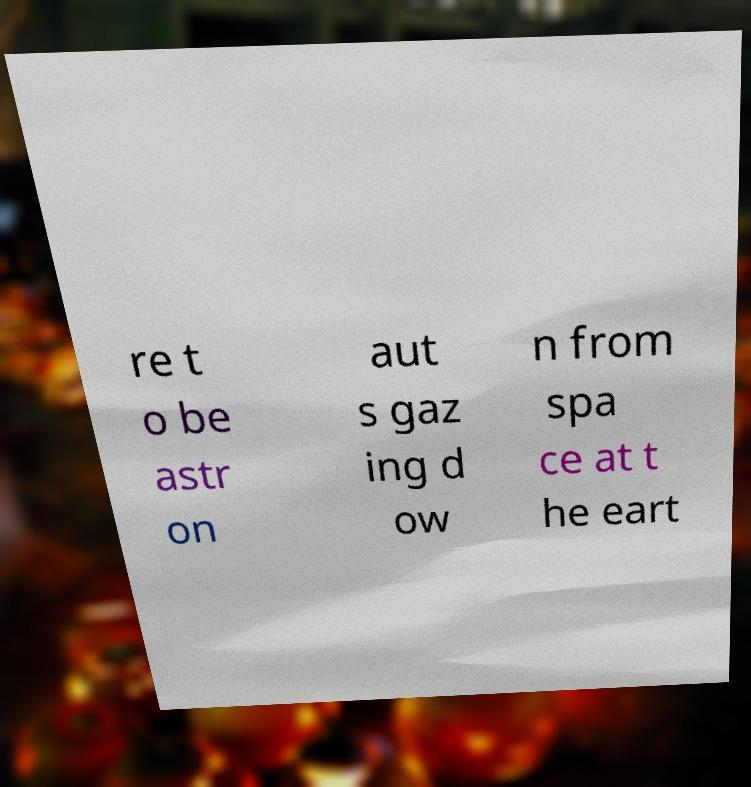Can you accurately transcribe the text from the provided image for me? re t o be astr on aut s gaz ing d ow n from spa ce at t he eart 